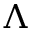<formula> <loc_0><loc_0><loc_500><loc_500>\Lambda</formula> 